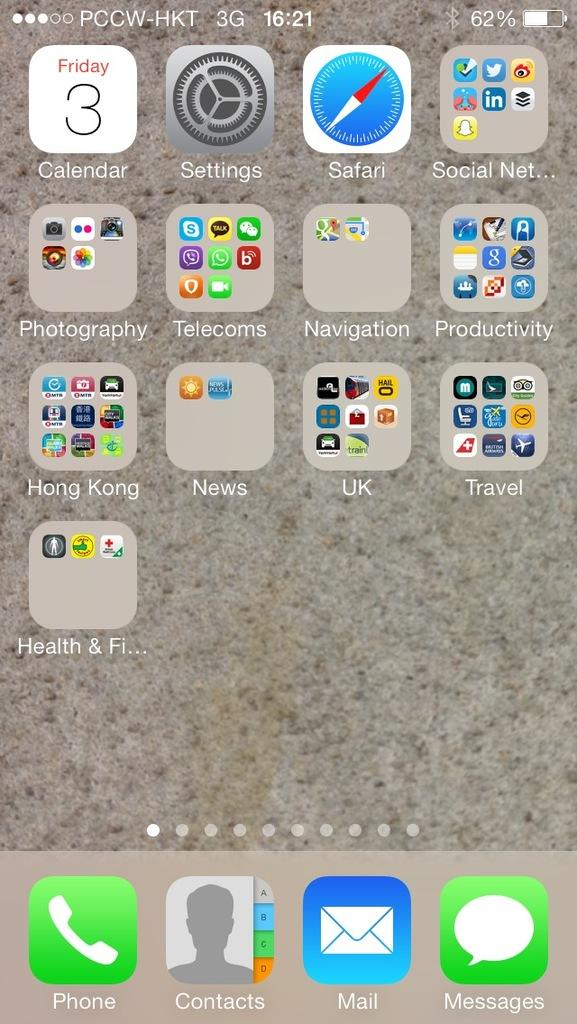What type of device is shown in the image? The image is a screenshot of an iPhone. What can be seen on the screen of the iPhone? There are icons and text visible in the image. What information is displayed at the top of the screen? The time is visible in the image. What is the background of the screen? There is a wallpaper in the image. What type of stew is being prepared in the image? There is no stew present in the image; it is a screenshot of an iPhone. How does the journey of the icons in the image progress? The icons in the image do not move or progress on a journey; they are static on the screen. 